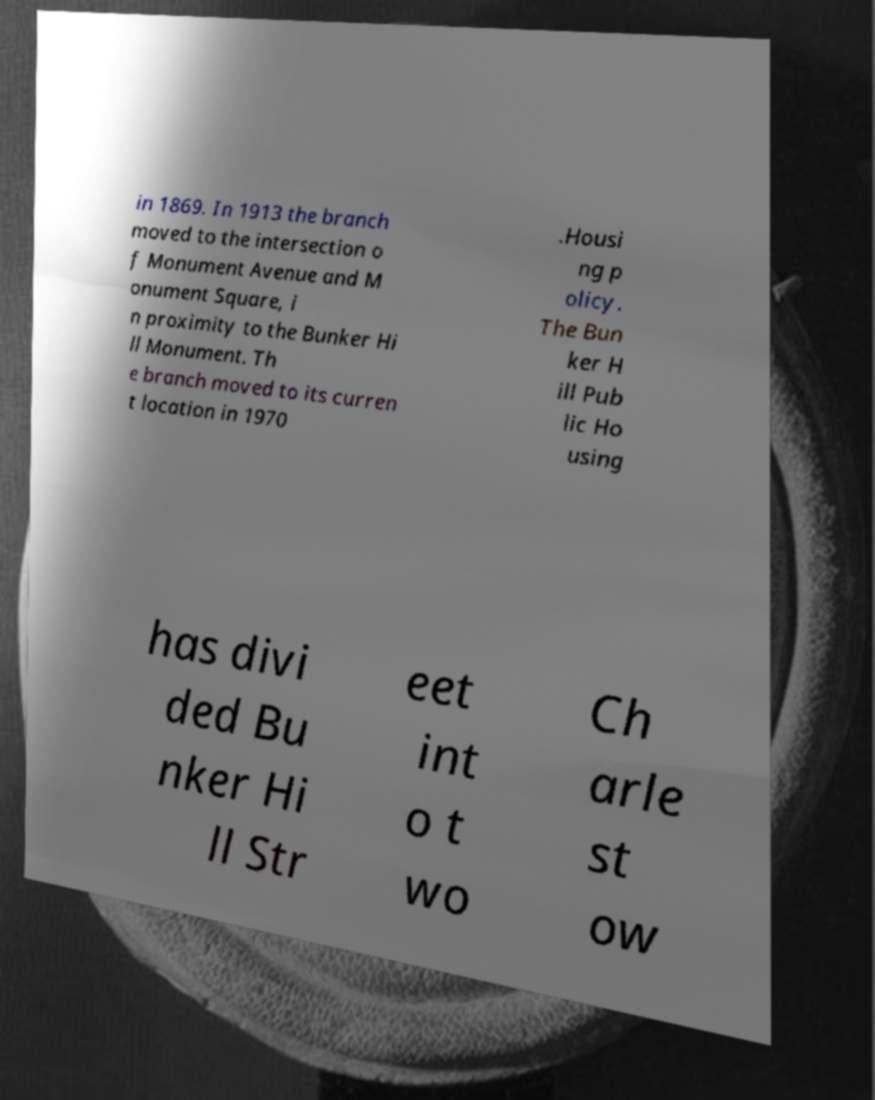Can you read and provide the text displayed in the image?This photo seems to have some interesting text. Can you extract and type it out for me? in 1869. In 1913 the branch moved to the intersection o f Monument Avenue and M onument Square, i n proximity to the Bunker Hi ll Monument. Th e branch moved to its curren t location in 1970 .Housi ng p olicy. The Bun ker H ill Pub lic Ho using has divi ded Bu nker Hi ll Str eet int o t wo Ch arle st ow 